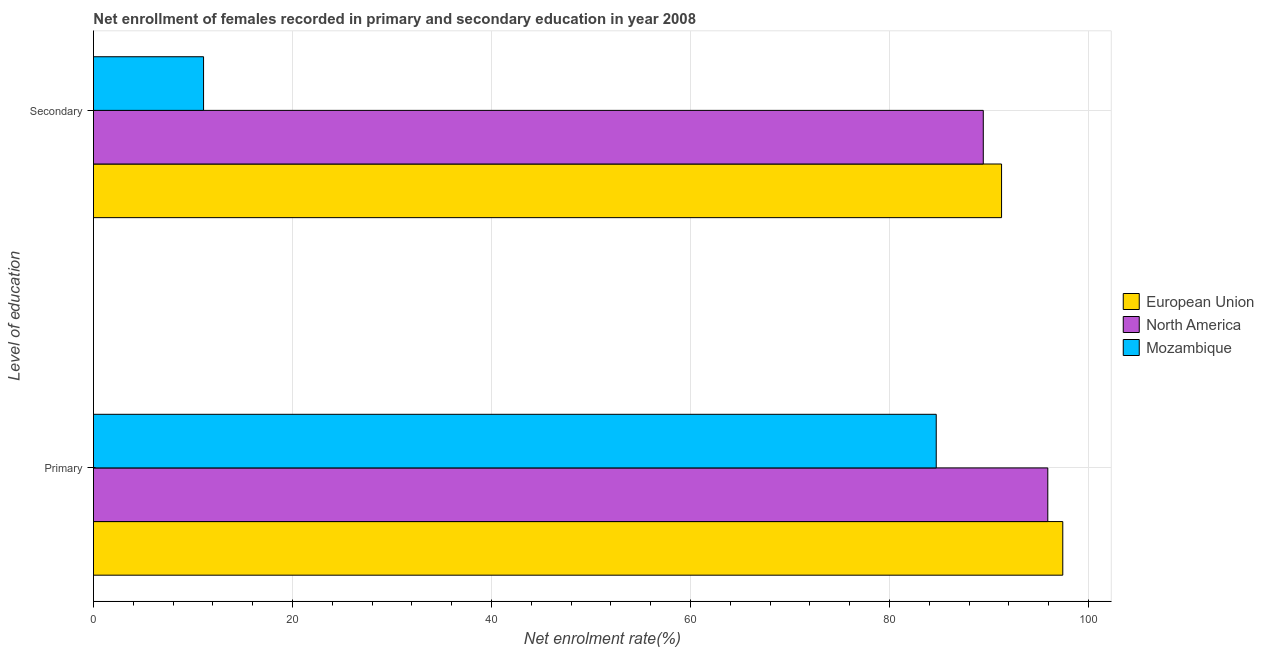How many different coloured bars are there?
Your response must be concise. 3. How many groups of bars are there?
Your response must be concise. 2. Are the number of bars per tick equal to the number of legend labels?
Keep it short and to the point. Yes. How many bars are there on the 2nd tick from the top?
Offer a very short reply. 3. What is the label of the 1st group of bars from the top?
Provide a succinct answer. Secondary. What is the enrollment rate in secondary education in North America?
Offer a very short reply. 89.43. Across all countries, what is the maximum enrollment rate in secondary education?
Give a very brief answer. 91.26. Across all countries, what is the minimum enrollment rate in primary education?
Offer a terse response. 84.7. In which country was the enrollment rate in primary education maximum?
Ensure brevity in your answer.  European Union. In which country was the enrollment rate in secondary education minimum?
Your answer should be very brief. Mozambique. What is the total enrollment rate in secondary education in the graph?
Keep it short and to the point. 191.75. What is the difference between the enrollment rate in primary education in European Union and that in North America?
Ensure brevity in your answer.  1.51. What is the difference between the enrollment rate in secondary education in European Union and the enrollment rate in primary education in North America?
Ensure brevity in your answer.  -4.65. What is the average enrollment rate in primary education per country?
Offer a terse response. 92.67. What is the difference between the enrollment rate in primary education and enrollment rate in secondary education in European Union?
Give a very brief answer. 6.15. What is the ratio of the enrollment rate in secondary education in Mozambique to that in North America?
Your answer should be compact. 0.12. What does the 3rd bar from the top in Secondary represents?
Your response must be concise. European Union. What does the 2nd bar from the bottom in Primary represents?
Your response must be concise. North America. How many countries are there in the graph?
Ensure brevity in your answer.  3. Are the values on the major ticks of X-axis written in scientific E-notation?
Offer a terse response. No. How many legend labels are there?
Provide a succinct answer. 3. How are the legend labels stacked?
Ensure brevity in your answer.  Vertical. What is the title of the graph?
Provide a short and direct response. Net enrollment of females recorded in primary and secondary education in year 2008. Does "French Polynesia" appear as one of the legend labels in the graph?
Your answer should be very brief. No. What is the label or title of the X-axis?
Give a very brief answer. Net enrolment rate(%). What is the label or title of the Y-axis?
Ensure brevity in your answer.  Level of education. What is the Net enrolment rate(%) in European Union in Primary?
Offer a very short reply. 97.41. What is the Net enrolment rate(%) in North America in Primary?
Make the answer very short. 95.91. What is the Net enrolment rate(%) of Mozambique in Primary?
Give a very brief answer. 84.7. What is the Net enrolment rate(%) in European Union in Secondary?
Keep it short and to the point. 91.26. What is the Net enrolment rate(%) in North America in Secondary?
Provide a succinct answer. 89.43. What is the Net enrolment rate(%) in Mozambique in Secondary?
Your answer should be compact. 11.06. Across all Level of education, what is the maximum Net enrolment rate(%) in European Union?
Give a very brief answer. 97.41. Across all Level of education, what is the maximum Net enrolment rate(%) in North America?
Keep it short and to the point. 95.91. Across all Level of education, what is the maximum Net enrolment rate(%) in Mozambique?
Offer a very short reply. 84.7. Across all Level of education, what is the minimum Net enrolment rate(%) of European Union?
Give a very brief answer. 91.26. Across all Level of education, what is the minimum Net enrolment rate(%) in North America?
Keep it short and to the point. 89.43. Across all Level of education, what is the minimum Net enrolment rate(%) in Mozambique?
Your answer should be compact. 11.06. What is the total Net enrolment rate(%) of European Union in the graph?
Offer a very short reply. 188.68. What is the total Net enrolment rate(%) of North America in the graph?
Make the answer very short. 185.34. What is the total Net enrolment rate(%) of Mozambique in the graph?
Offer a terse response. 95.76. What is the difference between the Net enrolment rate(%) of European Union in Primary and that in Secondary?
Offer a terse response. 6.15. What is the difference between the Net enrolment rate(%) of North America in Primary and that in Secondary?
Offer a terse response. 6.48. What is the difference between the Net enrolment rate(%) in Mozambique in Primary and that in Secondary?
Provide a succinct answer. 73.63. What is the difference between the Net enrolment rate(%) in European Union in Primary and the Net enrolment rate(%) in North America in Secondary?
Offer a terse response. 7.99. What is the difference between the Net enrolment rate(%) in European Union in Primary and the Net enrolment rate(%) in Mozambique in Secondary?
Offer a very short reply. 86.35. What is the difference between the Net enrolment rate(%) of North America in Primary and the Net enrolment rate(%) of Mozambique in Secondary?
Your response must be concise. 84.84. What is the average Net enrolment rate(%) of European Union per Level of education?
Your answer should be compact. 94.34. What is the average Net enrolment rate(%) of North America per Level of education?
Offer a very short reply. 92.67. What is the average Net enrolment rate(%) in Mozambique per Level of education?
Make the answer very short. 47.88. What is the difference between the Net enrolment rate(%) of European Union and Net enrolment rate(%) of North America in Primary?
Offer a terse response. 1.51. What is the difference between the Net enrolment rate(%) in European Union and Net enrolment rate(%) in Mozambique in Primary?
Offer a terse response. 12.72. What is the difference between the Net enrolment rate(%) in North America and Net enrolment rate(%) in Mozambique in Primary?
Your response must be concise. 11.21. What is the difference between the Net enrolment rate(%) of European Union and Net enrolment rate(%) of North America in Secondary?
Provide a succinct answer. 1.84. What is the difference between the Net enrolment rate(%) of European Union and Net enrolment rate(%) of Mozambique in Secondary?
Provide a short and direct response. 80.2. What is the difference between the Net enrolment rate(%) in North America and Net enrolment rate(%) in Mozambique in Secondary?
Offer a terse response. 78.36. What is the ratio of the Net enrolment rate(%) in European Union in Primary to that in Secondary?
Keep it short and to the point. 1.07. What is the ratio of the Net enrolment rate(%) of North America in Primary to that in Secondary?
Keep it short and to the point. 1.07. What is the ratio of the Net enrolment rate(%) of Mozambique in Primary to that in Secondary?
Keep it short and to the point. 7.65. What is the difference between the highest and the second highest Net enrolment rate(%) of European Union?
Your answer should be compact. 6.15. What is the difference between the highest and the second highest Net enrolment rate(%) of North America?
Keep it short and to the point. 6.48. What is the difference between the highest and the second highest Net enrolment rate(%) in Mozambique?
Ensure brevity in your answer.  73.63. What is the difference between the highest and the lowest Net enrolment rate(%) of European Union?
Ensure brevity in your answer.  6.15. What is the difference between the highest and the lowest Net enrolment rate(%) in North America?
Your answer should be compact. 6.48. What is the difference between the highest and the lowest Net enrolment rate(%) in Mozambique?
Ensure brevity in your answer.  73.63. 